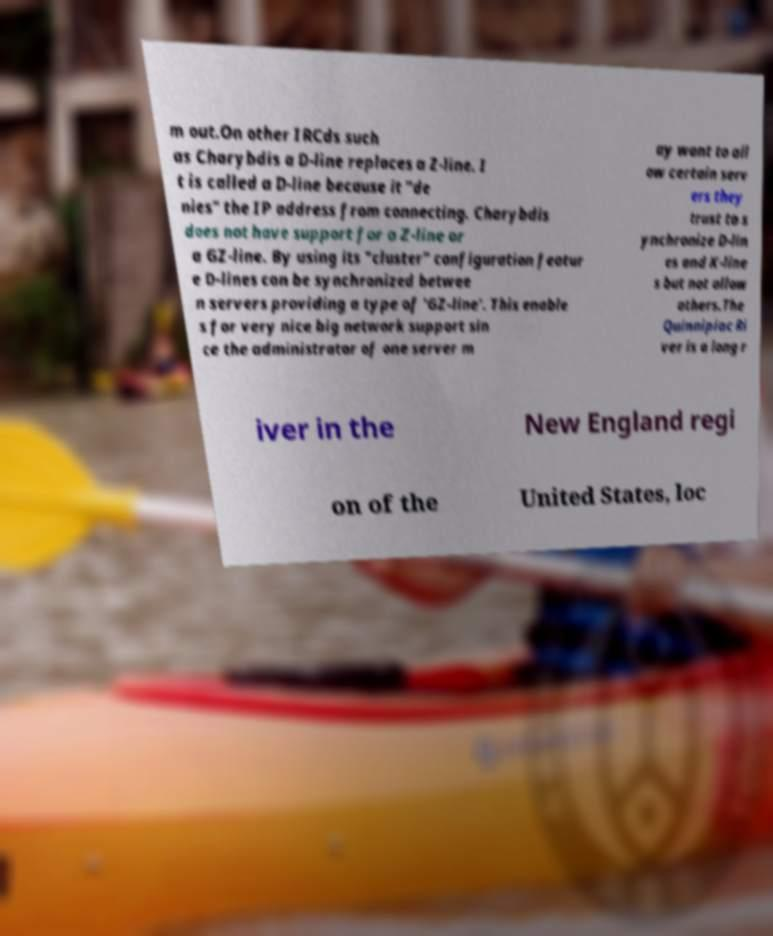Can you accurately transcribe the text from the provided image for me? m out.On other IRCds such as Charybdis a D-line replaces a Z-line. I t is called a D-line because it "de nies" the IP address from connecting. Charybdis does not have support for a Z-line or a GZ-line. By using its "cluster" configuration featur e D-lines can be synchronized betwee n servers providing a type of 'GZ-line'. This enable s for very nice big network support sin ce the administrator of one server m ay want to all ow certain serv ers they trust to s ynchronize D-lin es and K-line s but not allow others.The Quinnipiac Ri ver is a long r iver in the New England regi on of the United States, loc 